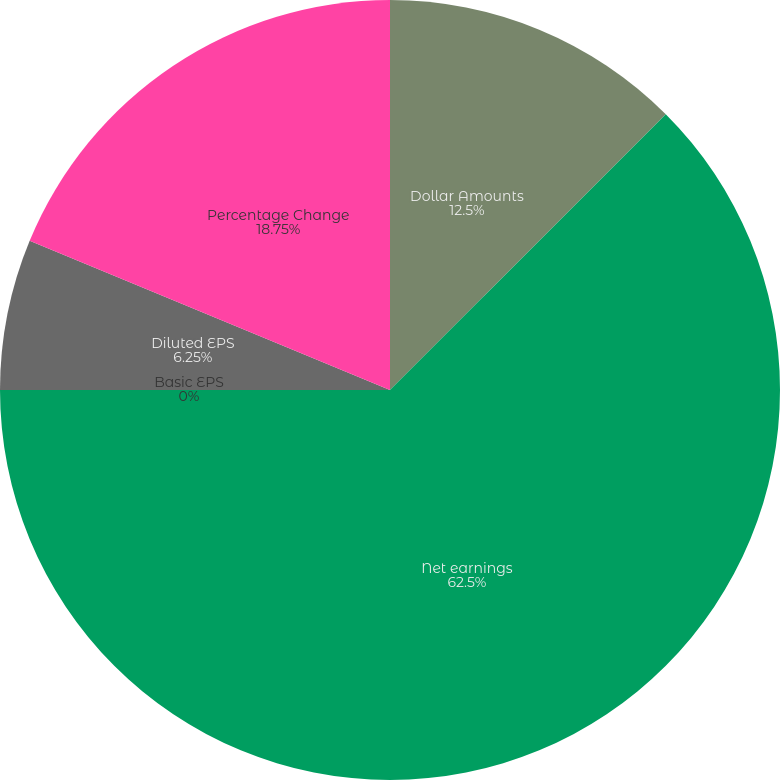<chart> <loc_0><loc_0><loc_500><loc_500><pie_chart><fcel>Dollar Amounts<fcel>Net earnings<fcel>Basic EPS<fcel>Diluted EPS<fcel>Percentage Change<nl><fcel>12.5%<fcel>62.5%<fcel>0.0%<fcel>6.25%<fcel>18.75%<nl></chart> 